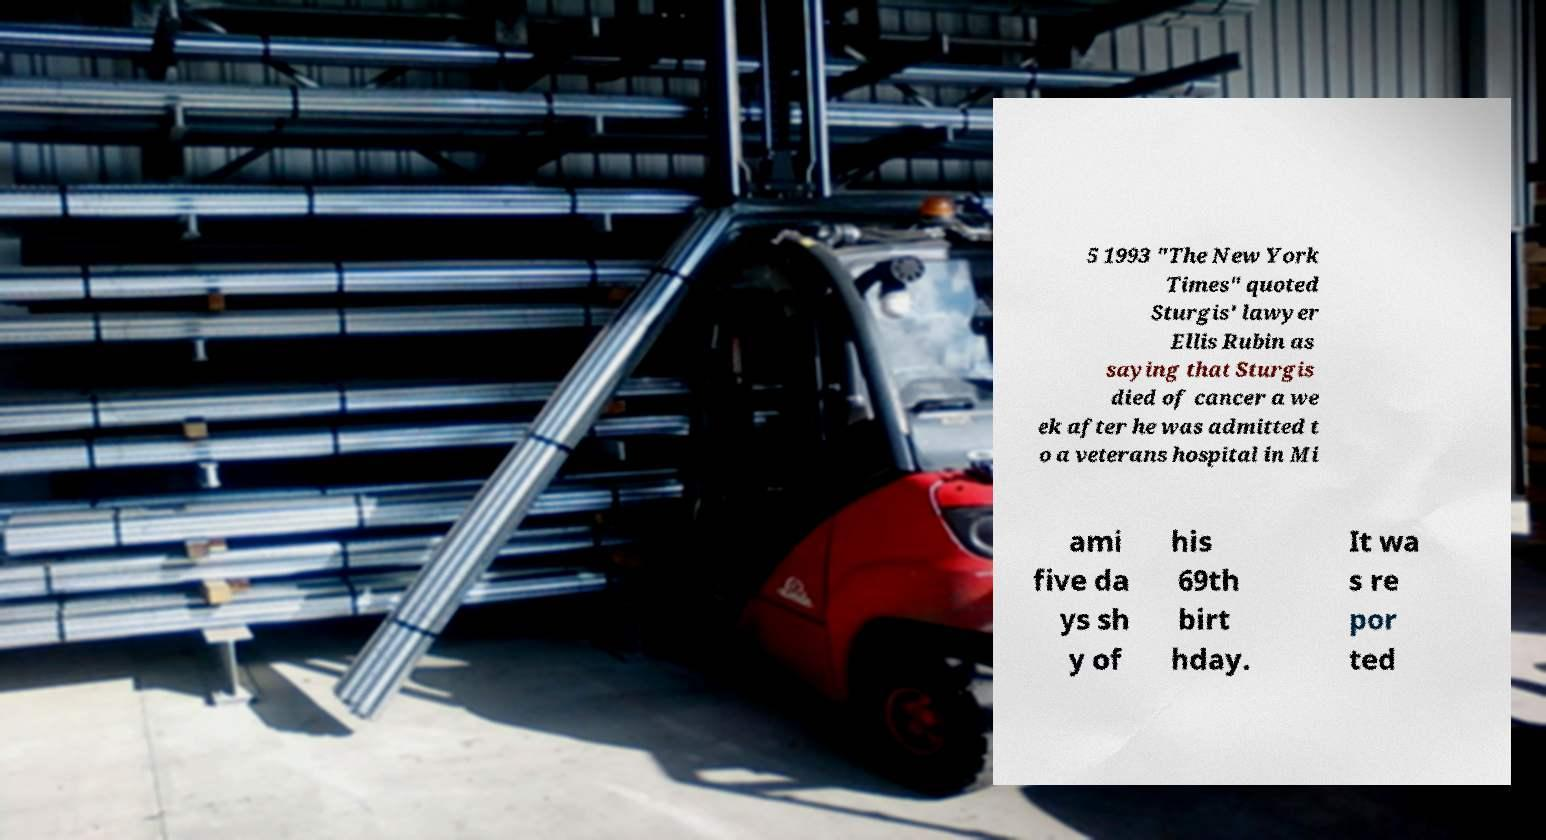For documentation purposes, I need the text within this image transcribed. Could you provide that? 5 1993 "The New York Times" quoted Sturgis' lawyer Ellis Rubin as saying that Sturgis died of cancer a we ek after he was admitted t o a veterans hospital in Mi ami five da ys sh y of his 69th birt hday. It wa s re por ted 